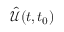<formula> <loc_0><loc_0><loc_500><loc_500>\hat { \mathcal { U } } ( t , t _ { 0 } )</formula> 